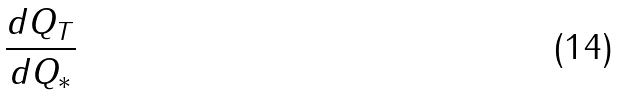Convert formula to latex. <formula><loc_0><loc_0><loc_500><loc_500>\frac { d Q _ { T } } { d Q _ { * } }</formula> 